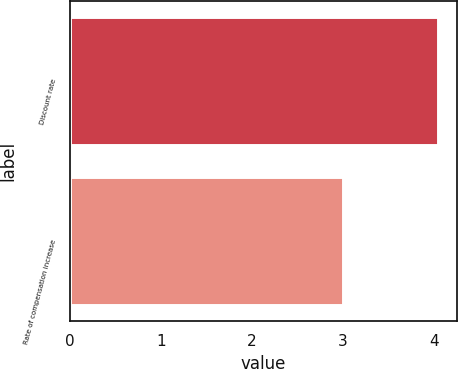Convert chart. <chart><loc_0><loc_0><loc_500><loc_500><bar_chart><fcel>Discount rate<fcel>Rate of compensation increase<nl><fcel>4.05<fcel>3<nl></chart> 